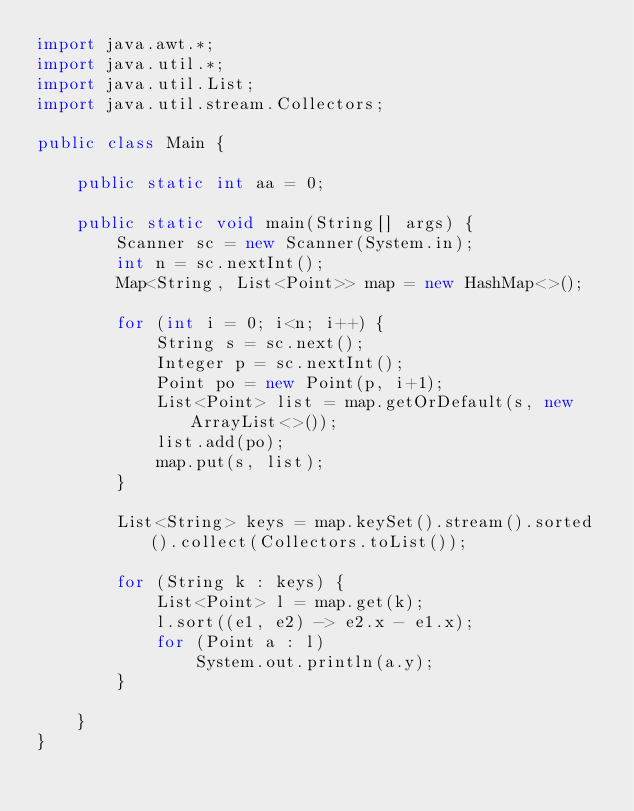Convert code to text. <code><loc_0><loc_0><loc_500><loc_500><_Java_>import java.awt.*;
import java.util.*;
import java.util.List;
import java.util.stream.Collectors;

public class Main {

    public static int aa = 0;

    public static void main(String[] args) {
        Scanner sc = new Scanner(System.in);
        int n = sc.nextInt();
        Map<String, List<Point>> map = new HashMap<>();

        for (int i = 0; i<n; i++) {
            String s = sc.next();
            Integer p = sc.nextInt();
            Point po = new Point(p, i+1);
            List<Point> list = map.getOrDefault(s, new ArrayList<>());
            list.add(po);
            map.put(s, list);
        }

        List<String> keys = map.keySet().stream().sorted().collect(Collectors.toList());

        for (String k : keys) {
            List<Point> l = map.get(k);
            l.sort((e1, e2) -> e2.x - e1.x);
            for (Point a : l)
                System.out.println(a.y);
        }

    }
}</code> 